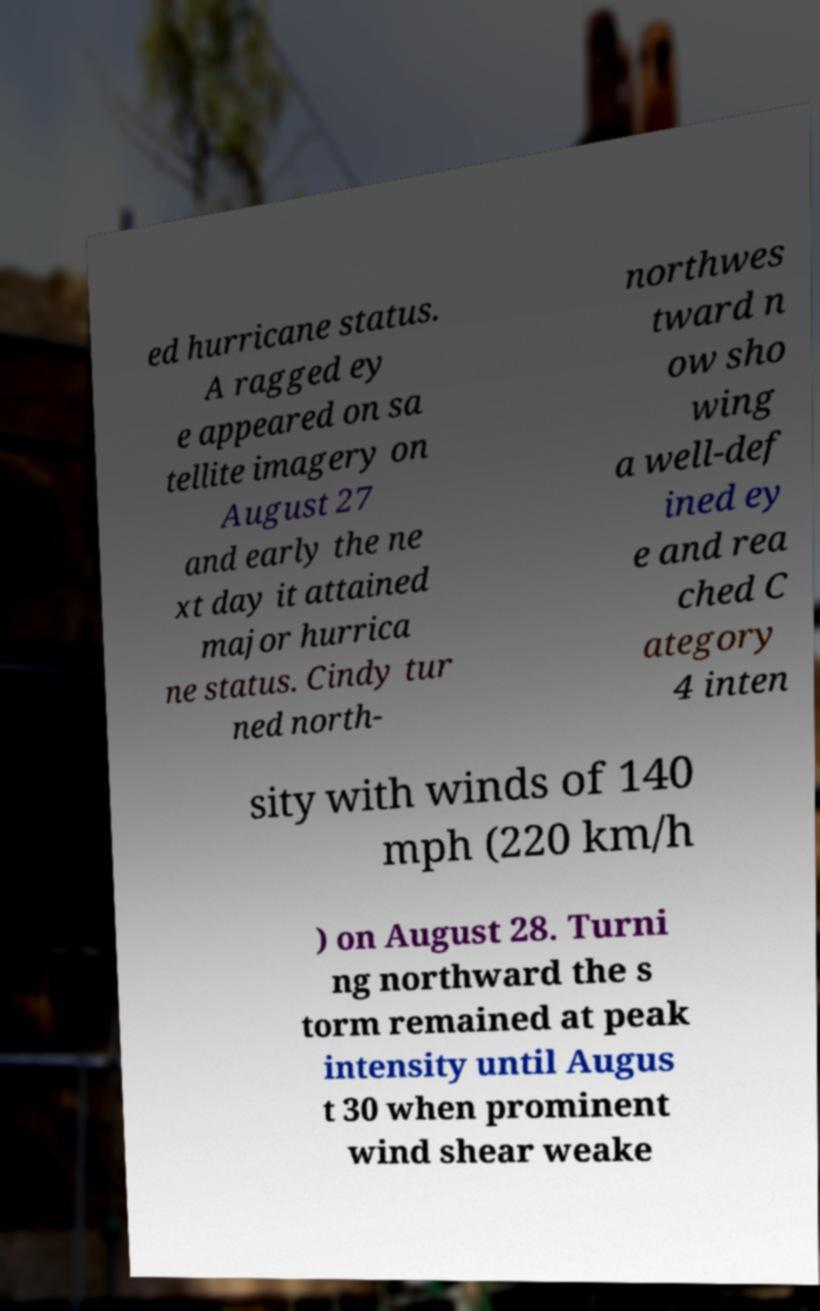Please identify and transcribe the text found in this image. ed hurricane status. A ragged ey e appeared on sa tellite imagery on August 27 and early the ne xt day it attained major hurrica ne status. Cindy tur ned north- northwes tward n ow sho wing a well-def ined ey e and rea ched C ategory 4 inten sity with winds of 140 mph (220 km/h ) on August 28. Turni ng northward the s torm remained at peak intensity until Augus t 30 when prominent wind shear weake 